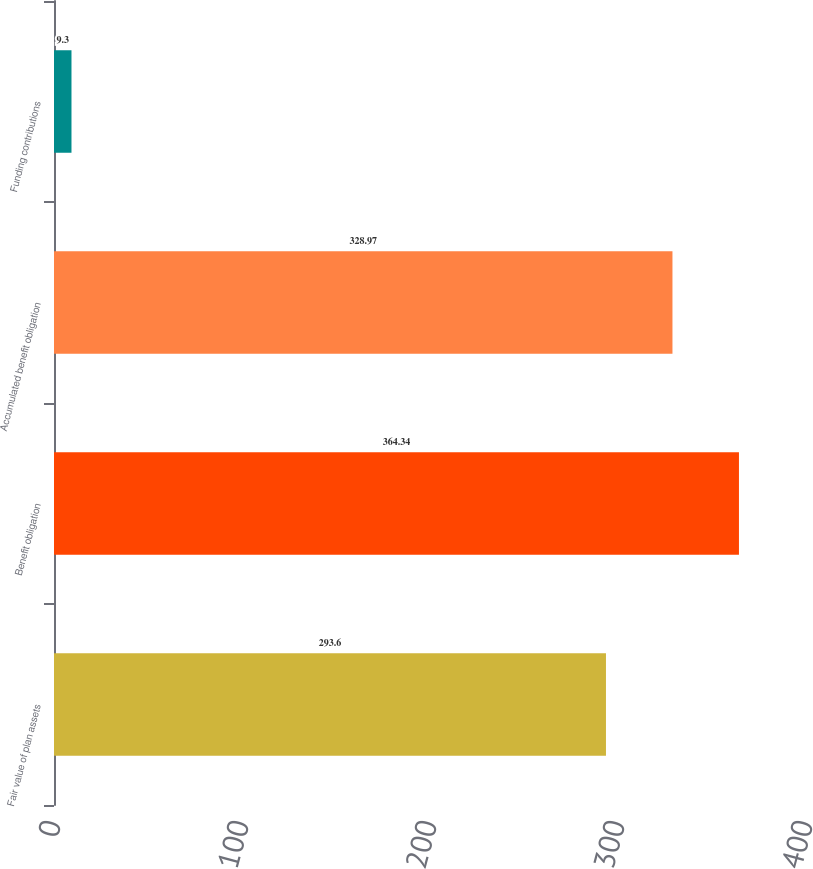Convert chart. <chart><loc_0><loc_0><loc_500><loc_500><bar_chart><fcel>Fair value of plan assets<fcel>Benefit obligation<fcel>Accumulated benefit obligation<fcel>Funding contributions<nl><fcel>293.6<fcel>364.34<fcel>328.97<fcel>9.3<nl></chart> 